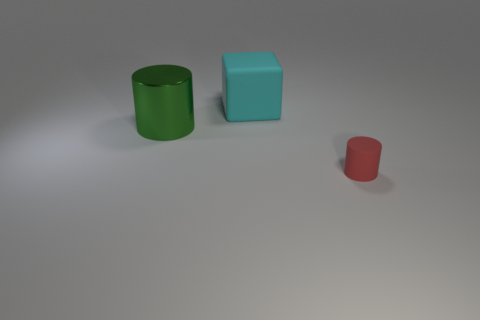Add 3 big blue rubber cylinders. How many objects exist? 6 Subtract all blocks. How many objects are left? 2 Subtract 1 red cylinders. How many objects are left? 2 Subtract all tiny brown metallic cylinders. Subtract all tiny matte things. How many objects are left? 2 Add 3 big metal objects. How many big metal objects are left? 4 Add 2 large shiny things. How many large shiny things exist? 3 